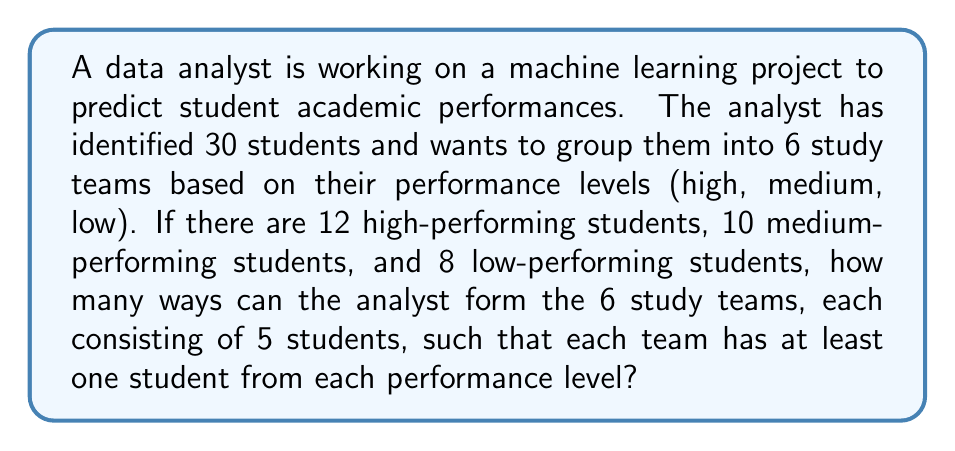What is the answer to this math problem? Let's approach this step-by-step:

1) First, we need to distribute one student from each performance level to each team. This ensures that each team has at least one student from each performance level.
   - 6 high-performing students
   - 6 medium-performing students
   - 6 low-performing students

2) Now, we have 12 students left to distribute:
   - 6 high-performing students (12 - 6 = 6)
   - 4 medium-performing students (10 - 6 = 4)
   - 2 low-performing students (8 - 6 = 2)

3) We need to distribute these 12 students among 6 teams, with each team getting 2 more students (5 - 3 = 2).

4) This is a classic stars and bars problem. We can use the formula:
   $$\binom{n+k-1}{k-1}$$
   where n is the number of items to distribute and k is the number of groups.

5) For high-performing students:
   $$\binom{6+6-1}{6-1} = \binom{11}{5} = 462$$

6) For medium-performing students:
   $$\binom{4+6-1}{6-1} = \binom{9}{5} = 126$$

7) For low-performing students:
   $$\binom{2+6-1}{6-1} = \binom{7}{5} = 21$$

8) By the multiplication principle, the total number of ways to form the teams is:
   $$462 \times 126 \times 21 = 1,220,292$$
Answer: 1,220,292 